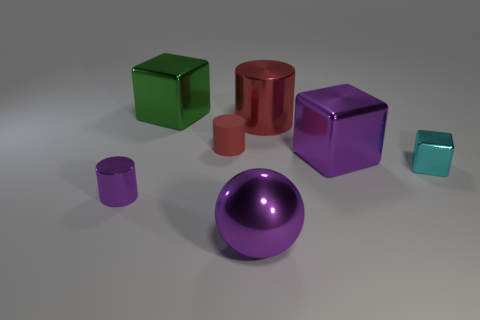Is the small shiny block the same color as the ball? no 